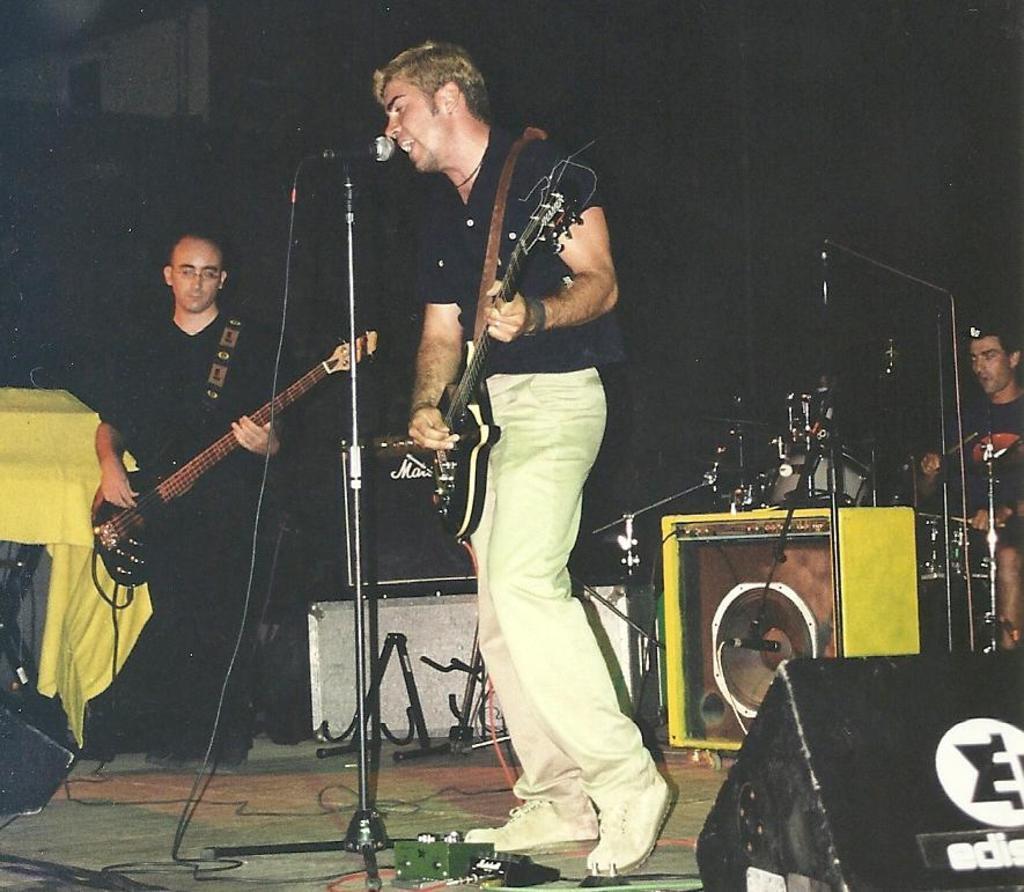Can you describe this image briefly? There are two members on the stage, who are playing guitars in their hands. One guy is singing in front of a mic and a stand. In the background there is another guy playing a musical instrument here. 